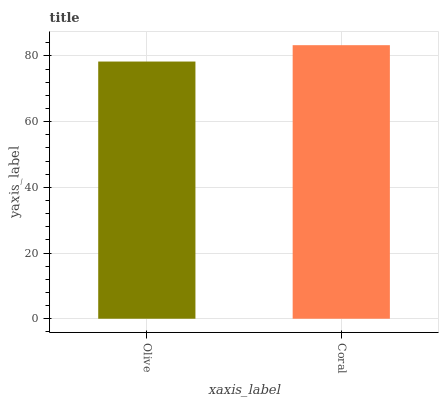Is Olive the minimum?
Answer yes or no. Yes. Is Coral the maximum?
Answer yes or no. Yes. Is Coral the minimum?
Answer yes or no. No. Is Coral greater than Olive?
Answer yes or no. Yes. Is Olive less than Coral?
Answer yes or no. Yes. Is Olive greater than Coral?
Answer yes or no. No. Is Coral less than Olive?
Answer yes or no. No. Is Coral the high median?
Answer yes or no. Yes. Is Olive the low median?
Answer yes or no. Yes. Is Olive the high median?
Answer yes or no. No. Is Coral the low median?
Answer yes or no. No. 